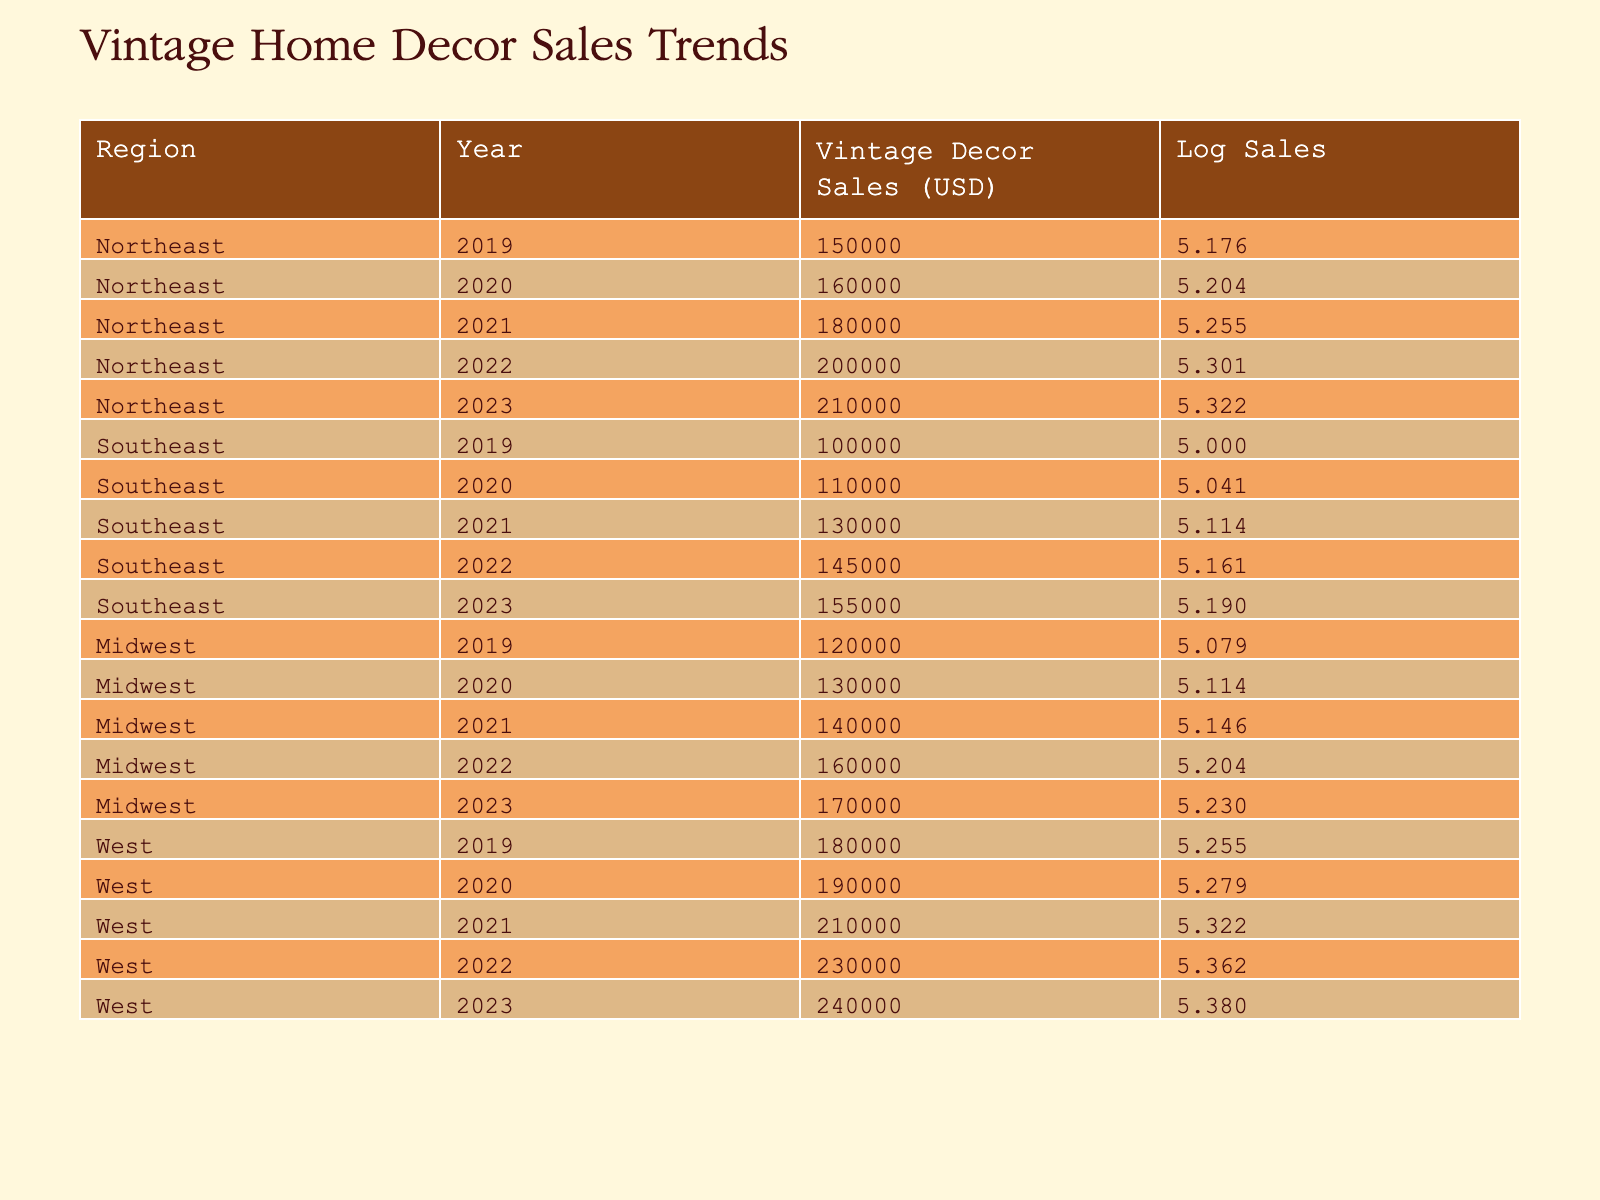What was the total vintage decor sales value in the West region in 2023? From the table, the vintage decor sales value in the West region for the year 2023 is listed as 240000 USD.
Answer: 240000 USD What is the log sales value for the Northeast region in 2021? The log sales value for the Northeast region in 2021 can be found in the table under that region and year, which shows a vintage decor sales value of 180000 USD. Its log sales value, calculated as log10(180000), is approximately 5.255.
Answer: 5.255 Which region had the highest sales increase from 2019 to 2023? To calculate the sales increase for each region: Northeast increased from 150000 to 210000 (60000), Southeast from 100000 to 155000 (55000), Midwest from 120000 to 170000 (50000), and West from 180000 to 240000 (60000). Both Northeast and West had the highest increase of 60000 USD.
Answer: Northeast and West Is there a year where Southeast's sales were greater than Midwest's sales? The table shows Southeast's sales for 2019 to 2023 and Midwest's for the same years. Especially in 2023, Southeast's sales were 155000 while Midwest's were 170000, indicating that there were no years where Southeast's sales exceeded those of Midwest.
Answer: No What is the average vintage decor sales value for the Midwest region over the five years? The sales values for the Midwest region across the five years are 120000, 130000, 140000, 160000, and 170000 USD. Summing these values gives 820000 USD. Dividing by 5 (the number of years) yields an average of 164000 USD.
Answer: 164000 USD How did the vintage decor sales in the Southeast compare to the West during the years where both had values? The annual sales for Southeast (2019: 100000, 2020: 110000, 2021: 130000, 2022: 145000, 2023: 155000) show consistently lower values compared to West's corresponding years (2019: 180000, 2020: 190000, 2021: 210000, 2022: 230000, 2023: 240000). Thus, Southeast's sales were less than West's in every year.
Answer: Southeast's sales were consistently lower 